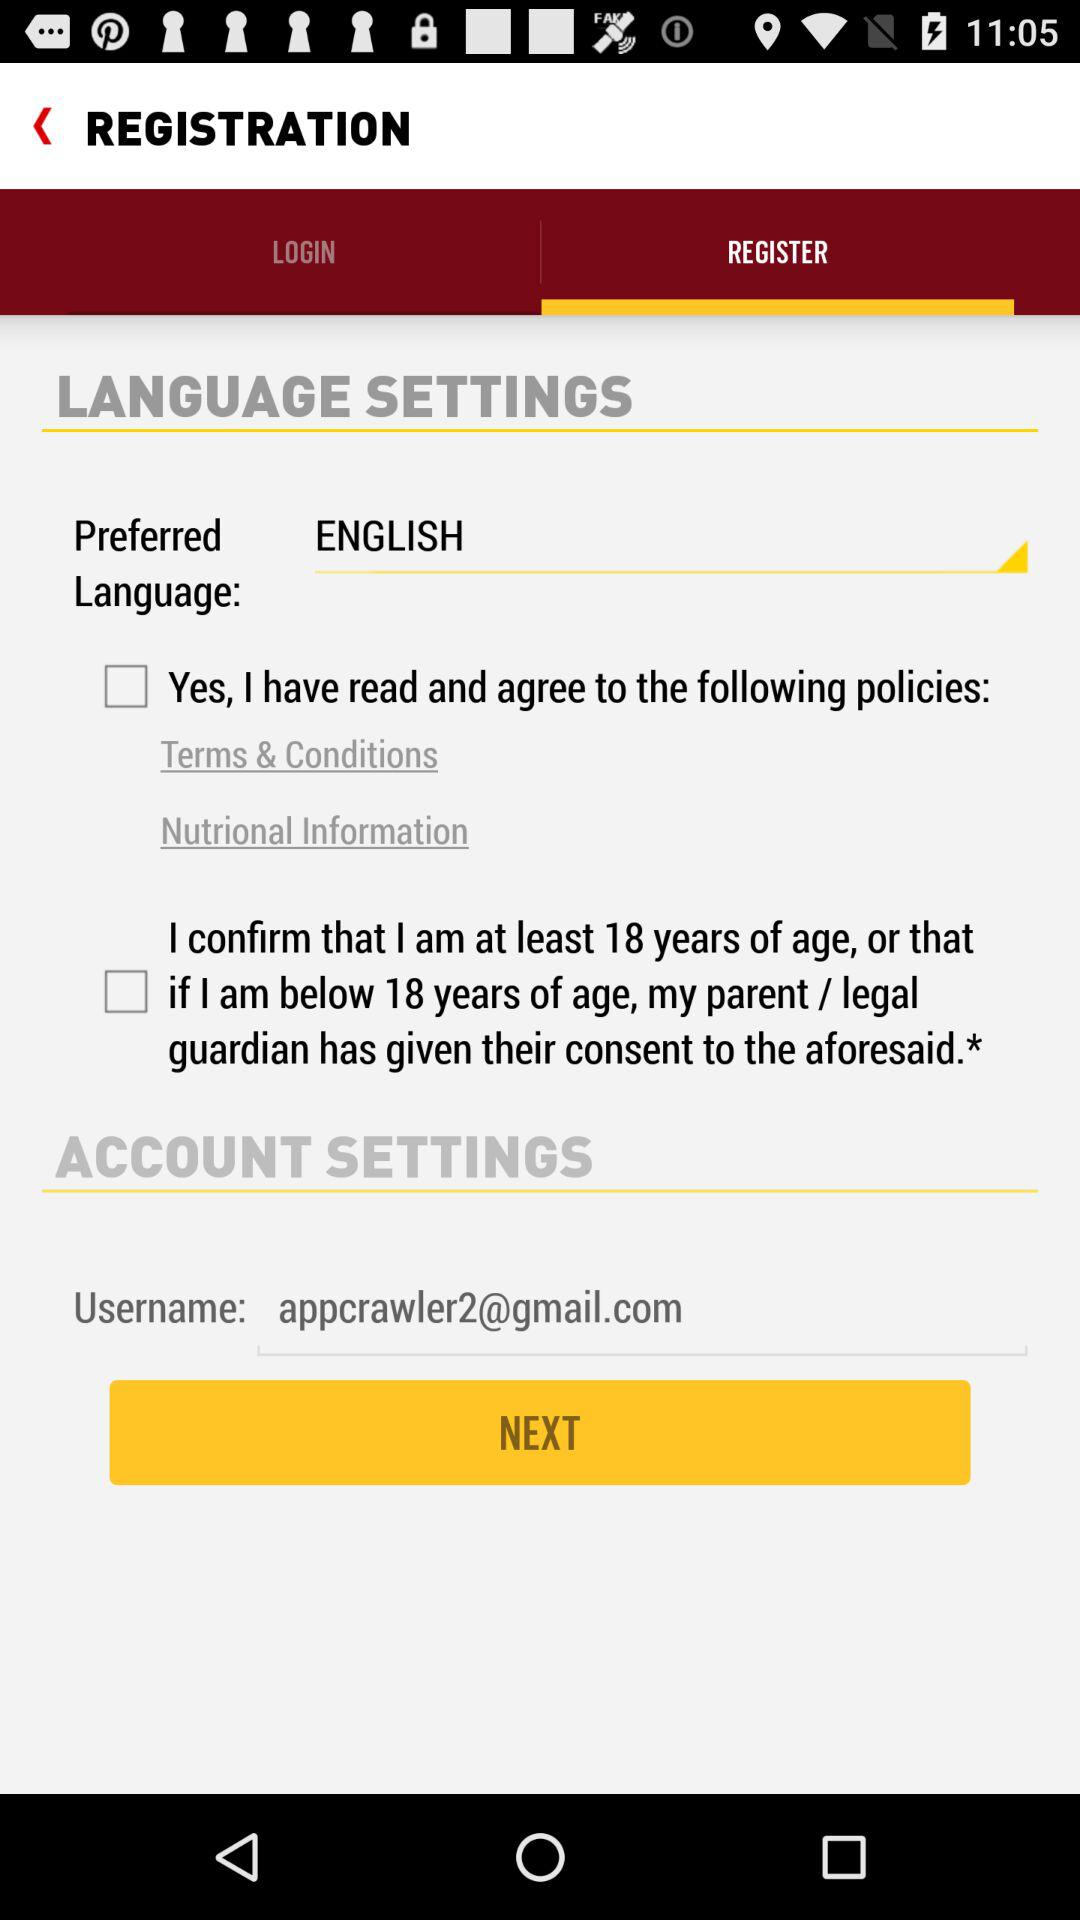Which language is selected? The selected language is English. 